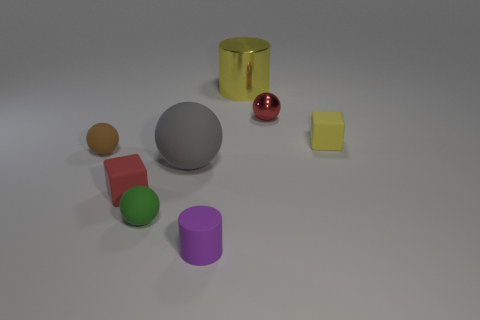Do the large matte ball and the block on the left side of the yellow matte block have the same color?
Offer a very short reply. No. What is the color of the matte thing that is on the left side of the tiny rubber cube that is in front of the matte block that is on the right side of the tiny matte cylinder?
Your response must be concise. Brown. What is the color of the large thing that is the same shape as the tiny brown thing?
Ensure brevity in your answer.  Gray. Is the number of yellow cylinders that are in front of the brown ball the same as the number of brown matte blocks?
Offer a very short reply. Yes. What number of cylinders are either tiny brown metallic things or red metallic objects?
Ensure brevity in your answer.  0. There is a cylinder that is the same material as the big sphere; what color is it?
Offer a terse response. Purple. Is the material of the small red block the same as the tiny ball that is in front of the brown rubber object?
Your answer should be very brief. Yes. How many things are either big blue rubber balls or yellow objects?
Offer a very short reply. 2. Are there any other brown objects that have the same shape as the large rubber object?
Your answer should be very brief. Yes. There is a small purple thing; what number of matte balls are in front of it?
Offer a very short reply. 0. 